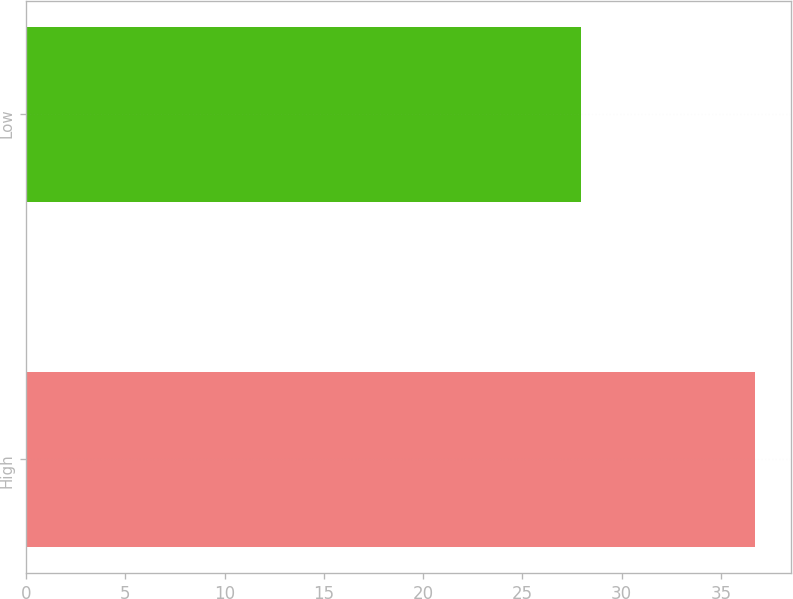Convert chart to OTSL. <chart><loc_0><loc_0><loc_500><loc_500><bar_chart><fcel>High<fcel>Low<nl><fcel>36.72<fcel>27.96<nl></chart> 